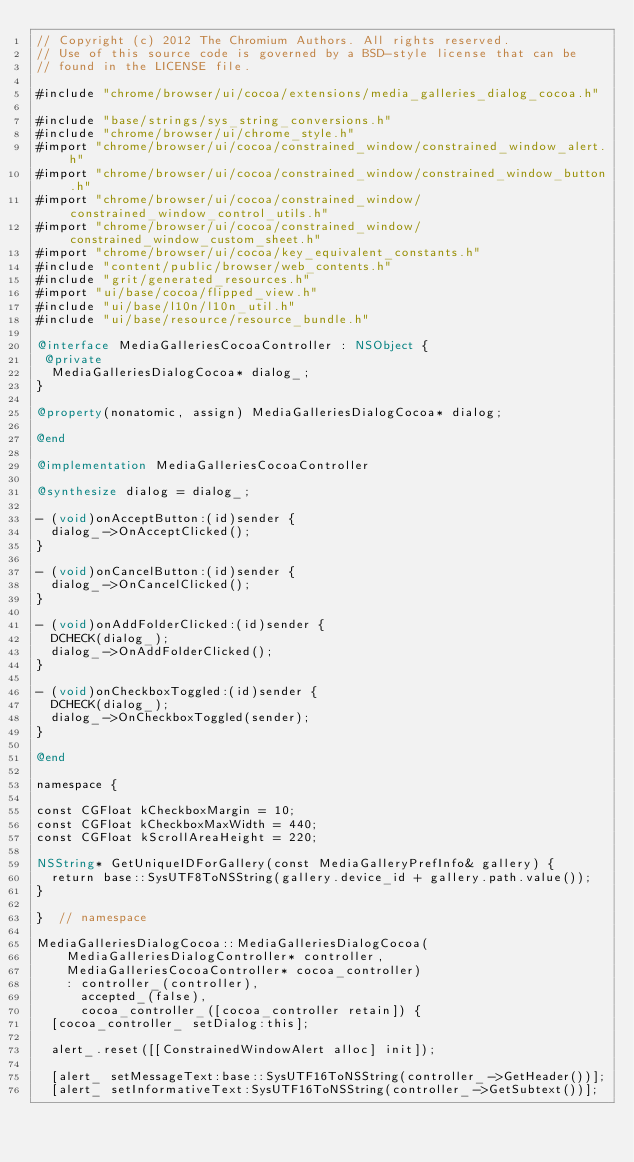Convert code to text. <code><loc_0><loc_0><loc_500><loc_500><_ObjectiveC_>// Copyright (c) 2012 The Chromium Authors. All rights reserved.
// Use of this source code is governed by a BSD-style license that can be
// found in the LICENSE file.

#include "chrome/browser/ui/cocoa/extensions/media_galleries_dialog_cocoa.h"

#include "base/strings/sys_string_conversions.h"
#include "chrome/browser/ui/chrome_style.h"
#import "chrome/browser/ui/cocoa/constrained_window/constrained_window_alert.h"
#import "chrome/browser/ui/cocoa/constrained_window/constrained_window_button.h"
#import "chrome/browser/ui/cocoa/constrained_window/constrained_window_control_utils.h"
#import "chrome/browser/ui/cocoa/constrained_window/constrained_window_custom_sheet.h"
#import "chrome/browser/ui/cocoa/key_equivalent_constants.h"
#include "content/public/browser/web_contents.h"
#include "grit/generated_resources.h"
#import "ui/base/cocoa/flipped_view.h"
#include "ui/base/l10n/l10n_util.h"
#include "ui/base/resource/resource_bundle.h"

@interface MediaGalleriesCocoaController : NSObject {
 @private
  MediaGalleriesDialogCocoa* dialog_;
}

@property(nonatomic, assign) MediaGalleriesDialogCocoa* dialog;

@end

@implementation MediaGalleriesCocoaController

@synthesize dialog = dialog_;

- (void)onAcceptButton:(id)sender {
  dialog_->OnAcceptClicked();
}

- (void)onCancelButton:(id)sender {
  dialog_->OnCancelClicked();
}

- (void)onAddFolderClicked:(id)sender {
  DCHECK(dialog_);
  dialog_->OnAddFolderClicked();
}

- (void)onCheckboxToggled:(id)sender {
  DCHECK(dialog_);
  dialog_->OnCheckboxToggled(sender);
}

@end

namespace {

const CGFloat kCheckboxMargin = 10;
const CGFloat kCheckboxMaxWidth = 440;
const CGFloat kScrollAreaHeight = 220;

NSString* GetUniqueIDForGallery(const MediaGalleryPrefInfo& gallery) {
  return base::SysUTF8ToNSString(gallery.device_id + gallery.path.value());
}

}  // namespace

MediaGalleriesDialogCocoa::MediaGalleriesDialogCocoa(
    MediaGalleriesDialogController* controller,
    MediaGalleriesCocoaController* cocoa_controller)
    : controller_(controller),
      accepted_(false),
      cocoa_controller_([cocoa_controller retain]) {
  [cocoa_controller_ setDialog:this];

  alert_.reset([[ConstrainedWindowAlert alloc] init]);

  [alert_ setMessageText:base::SysUTF16ToNSString(controller_->GetHeader())];
  [alert_ setInformativeText:SysUTF16ToNSString(controller_->GetSubtext())];</code> 